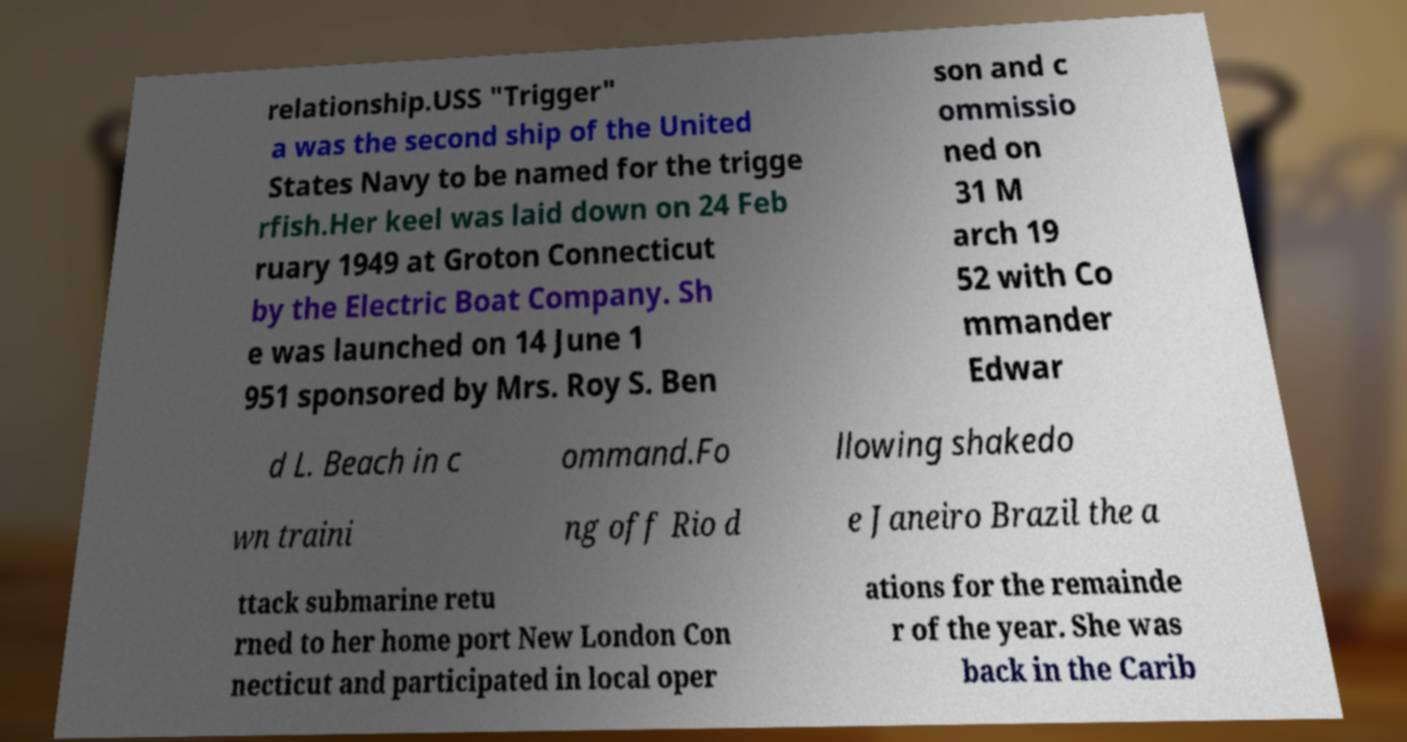Can you accurately transcribe the text from the provided image for me? relationship.USS "Trigger" a was the second ship of the United States Navy to be named for the trigge rfish.Her keel was laid down on 24 Feb ruary 1949 at Groton Connecticut by the Electric Boat Company. Sh e was launched on 14 June 1 951 sponsored by Mrs. Roy S. Ben son and c ommissio ned on 31 M arch 19 52 with Co mmander Edwar d L. Beach in c ommand.Fo llowing shakedo wn traini ng off Rio d e Janeiro Brazil the a ttack submarine retu rned to her home port New London Con necticut and participated in local oper ations for the remainde r of the year. She was back in the Carib 